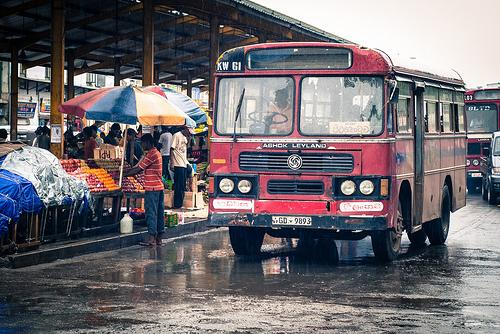Describe the bus in the image and mention any distinctive features. The bus is an old-style, big red bus with multiple colors, a white license plate, black metal bumper, headlights, windshield, and passenger windows. It's parked on the side of the road. What type of clothing is the man in the image wearing and what does it look like? The man is wearing an orange and white striped shirt, and blue pants. How would you summarize the overall atmosphere and setting of this image? It's an open outdoor market with a fruit stand, a man selling fruits, multi-colored umbrellas, a big red bus parked on the wet street, and grey cloudy skies overhead. What purpose do the blue and grey tarps in the image serve? The blue and grey tarps are covering a table, likely for protecting items such as fruits from the rain and other elements. What is the interaction between the man and his surroundings in the image? The man is standing in an open outdoor market, possibly selling fruits at a fruit stand with colorful umbrellas overhead, and a wet street due to rain. Identify and list the main elements observed in the image. Man with striped shirt, fruit stand, fresh oranges, fresh apples, big red bus, multi-colored umbrellas, wet street, blue and grey tarps, license plate, and cloudy skies. What kind of weather seems to be depicted in the image? The weather appears to be cloudy and possibly rainy, as the street is wet and there are grey cloudy skies overhead. What are the main colors of the umbrellas in the image? The umbrellas are multi-colored, featuring red, yellow, and blue colors. Briefly describe the state of the street in the image and any contributing factor. The street is wet from rain, with black asphalt surface and water floating on it. How many different types of fruits are mentioned in the image and what are they? Two types of fruits are mentioned: fresh oranges and fresh apples. Name the different types of fruit available at the market. oranges and apples What color is the bus? Choose from the following options: blue, green, or red. red Did it rain in the scene? Yes Describe the scene depicted in the image. An open outdoor market with a red bus parked on the side of the road, people, and a fruit stand with colorful umbrellas. Distinguish the color of fruit stand umbrellas. The umbrellas are colorful and multi-colored. What is the surface of the road like in the image? The road is made of black asphalt and is wet from rain. Is the license plate of the bus white or black? Choose from the options. white State the colors of the bus. The bus is mostly red with multiple colors. Is there any water present in the image? If so, where is it located? Yes, there's floating water in the market and on the road. Give a brief description of the man standing under the umbrella. The man is wearing an orange and white striped shirt, blue pants, and is standing under a multi-colored umbrella. What type of tarp covers the fruit stand in the market? Blue and silver tarps cover the fruit stand. Create a short poem describing the image. In the bustling market scene, where colors convene, How does the weather look in the scene? The sky is filled with grey clouds. What color are the striped shirt and pants worn by the man standing in the market? The shirt is orange and white, and the pants are blue. What color are the fresh oranges in the market? orange Describe the umbrella in the market scene. The umbrella is large, multi-colored, and provides shelter for the fruit stand. Identify the multi-colored object that provides shelter in the market. umbrellas Identify the object in the market with gray color. The tarp is gray. What is on the sidewalk in the image? A jug is on the sidewalk. 